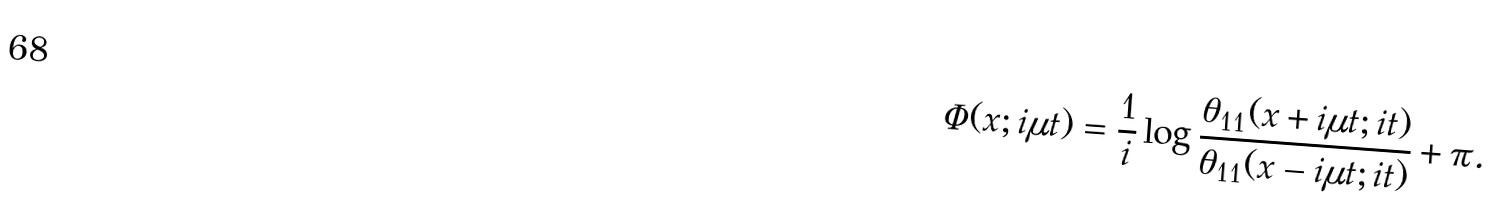Convert formula to latex. <formula><loc_0><loc_0><loc_500><loc_500>\Phi ( x ; i \mu t ) = \frac { 1 } { i } \log \frac { \theta _ { 1 1 } ( x + i \mu t ; i t ) } { \theta _ { 1 1 } ( x - i \mu t ; i t ) } + \pi .</formula> 